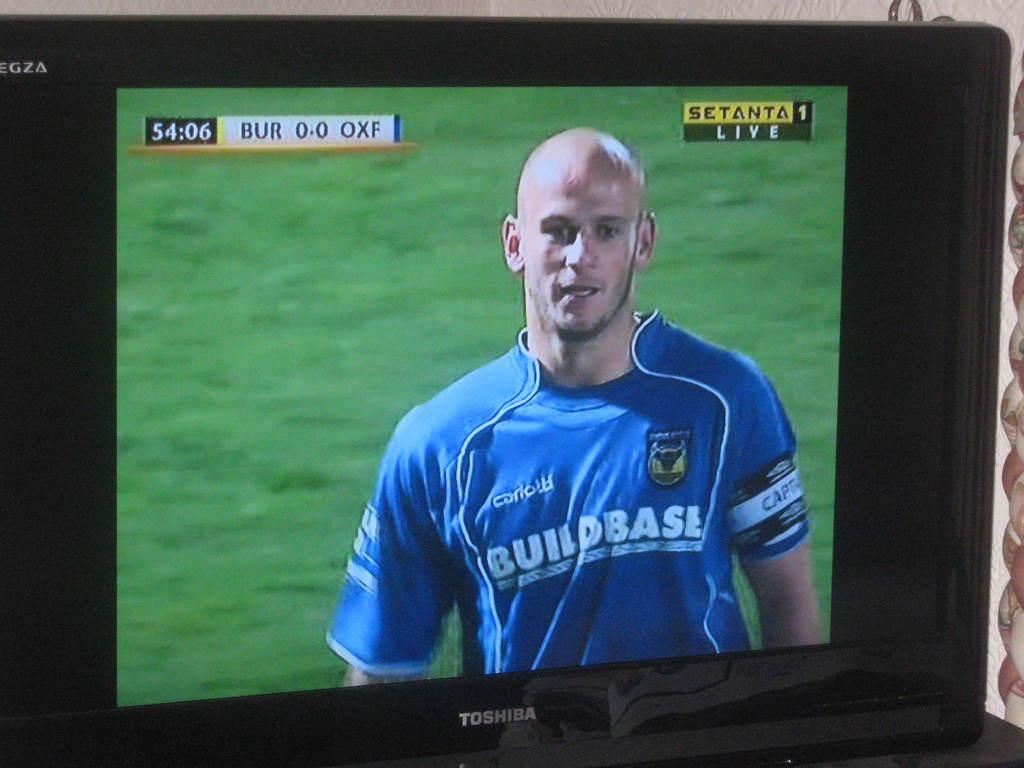<image>
Provide a brief description of the given image. a shirt that says Build Base on it 